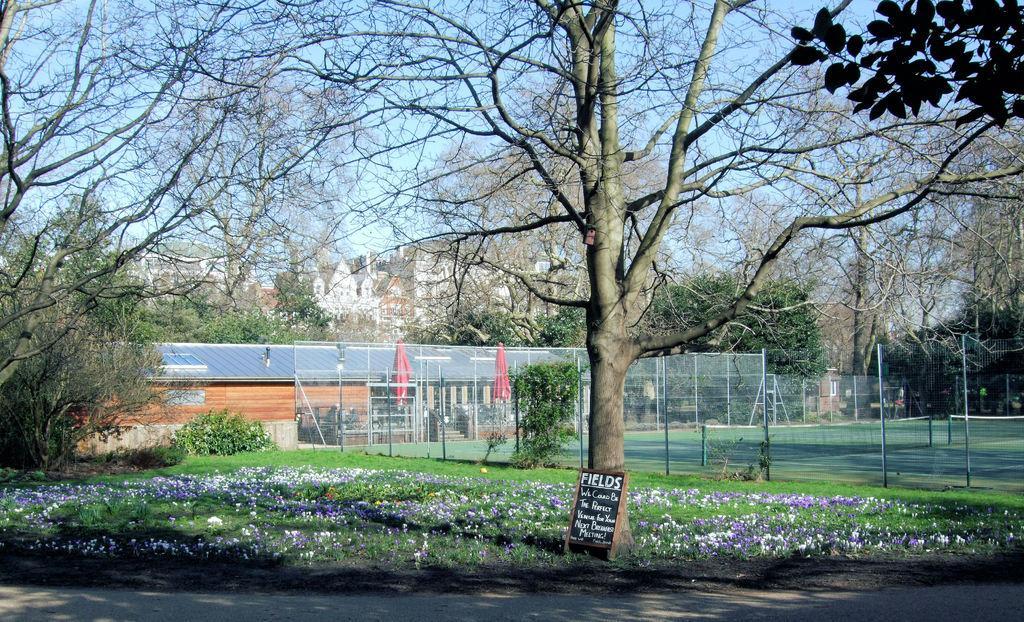In one or two sentences, can you explain what this image depicts? At the bottom of the image there is a road. Behind that on the ground there is grass and also there are flowers. There is a tree and in front of the tree there is a board with something written on it. Behind them there is fencing. Behind the fencing there is a court with nets. And also there are buildings with roofs and walls. There are many trees. Behind the trees there are buildings. And also there is sky in the background. 